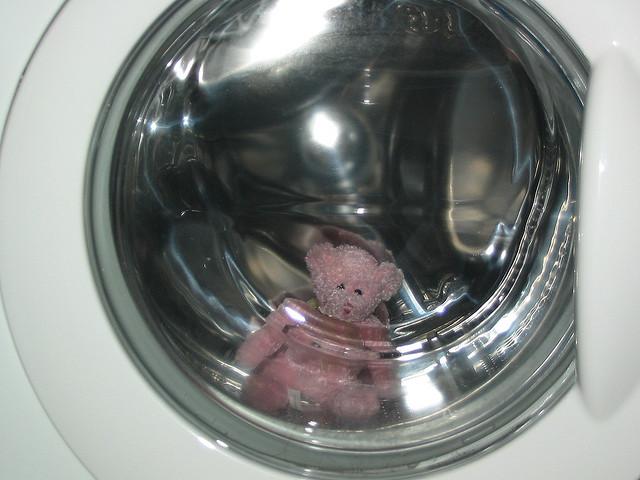What is the bear in?
Be succinct. Dryer. What color is the bear?
Short answer required. Pink. Why is the bear in the washing machine?
Be succinct. Dirty. 